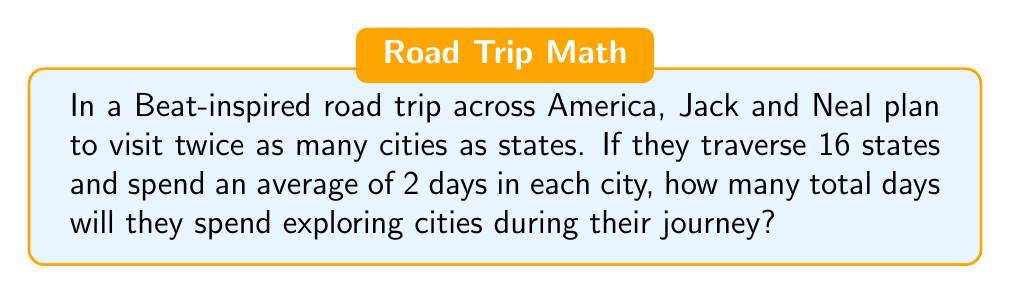What is the answer to this math problem? Let's break this down step-by-step:

1) First, we need to find the number of cities visited:
   - The number of cities is twice the number of states
   - Number of states = 16
   - Number of cities = $2 \times 16 = 32$

2) Now we know:
   - Number of cities visited = 32
   - Average days spent in each city = 2

3) To find the total days spent exploring cities, we multiply:
   $$ \text{Total days} = \text{Number of cities} \times \text{Days per city} $$
   $$ \text{Total days} = 32 \times 2 = 64 $$

Therefore, Jack and Neal will spend 64 days exploring cities during their Beat-inspired cross-country adventure.
Answer: 64 days 